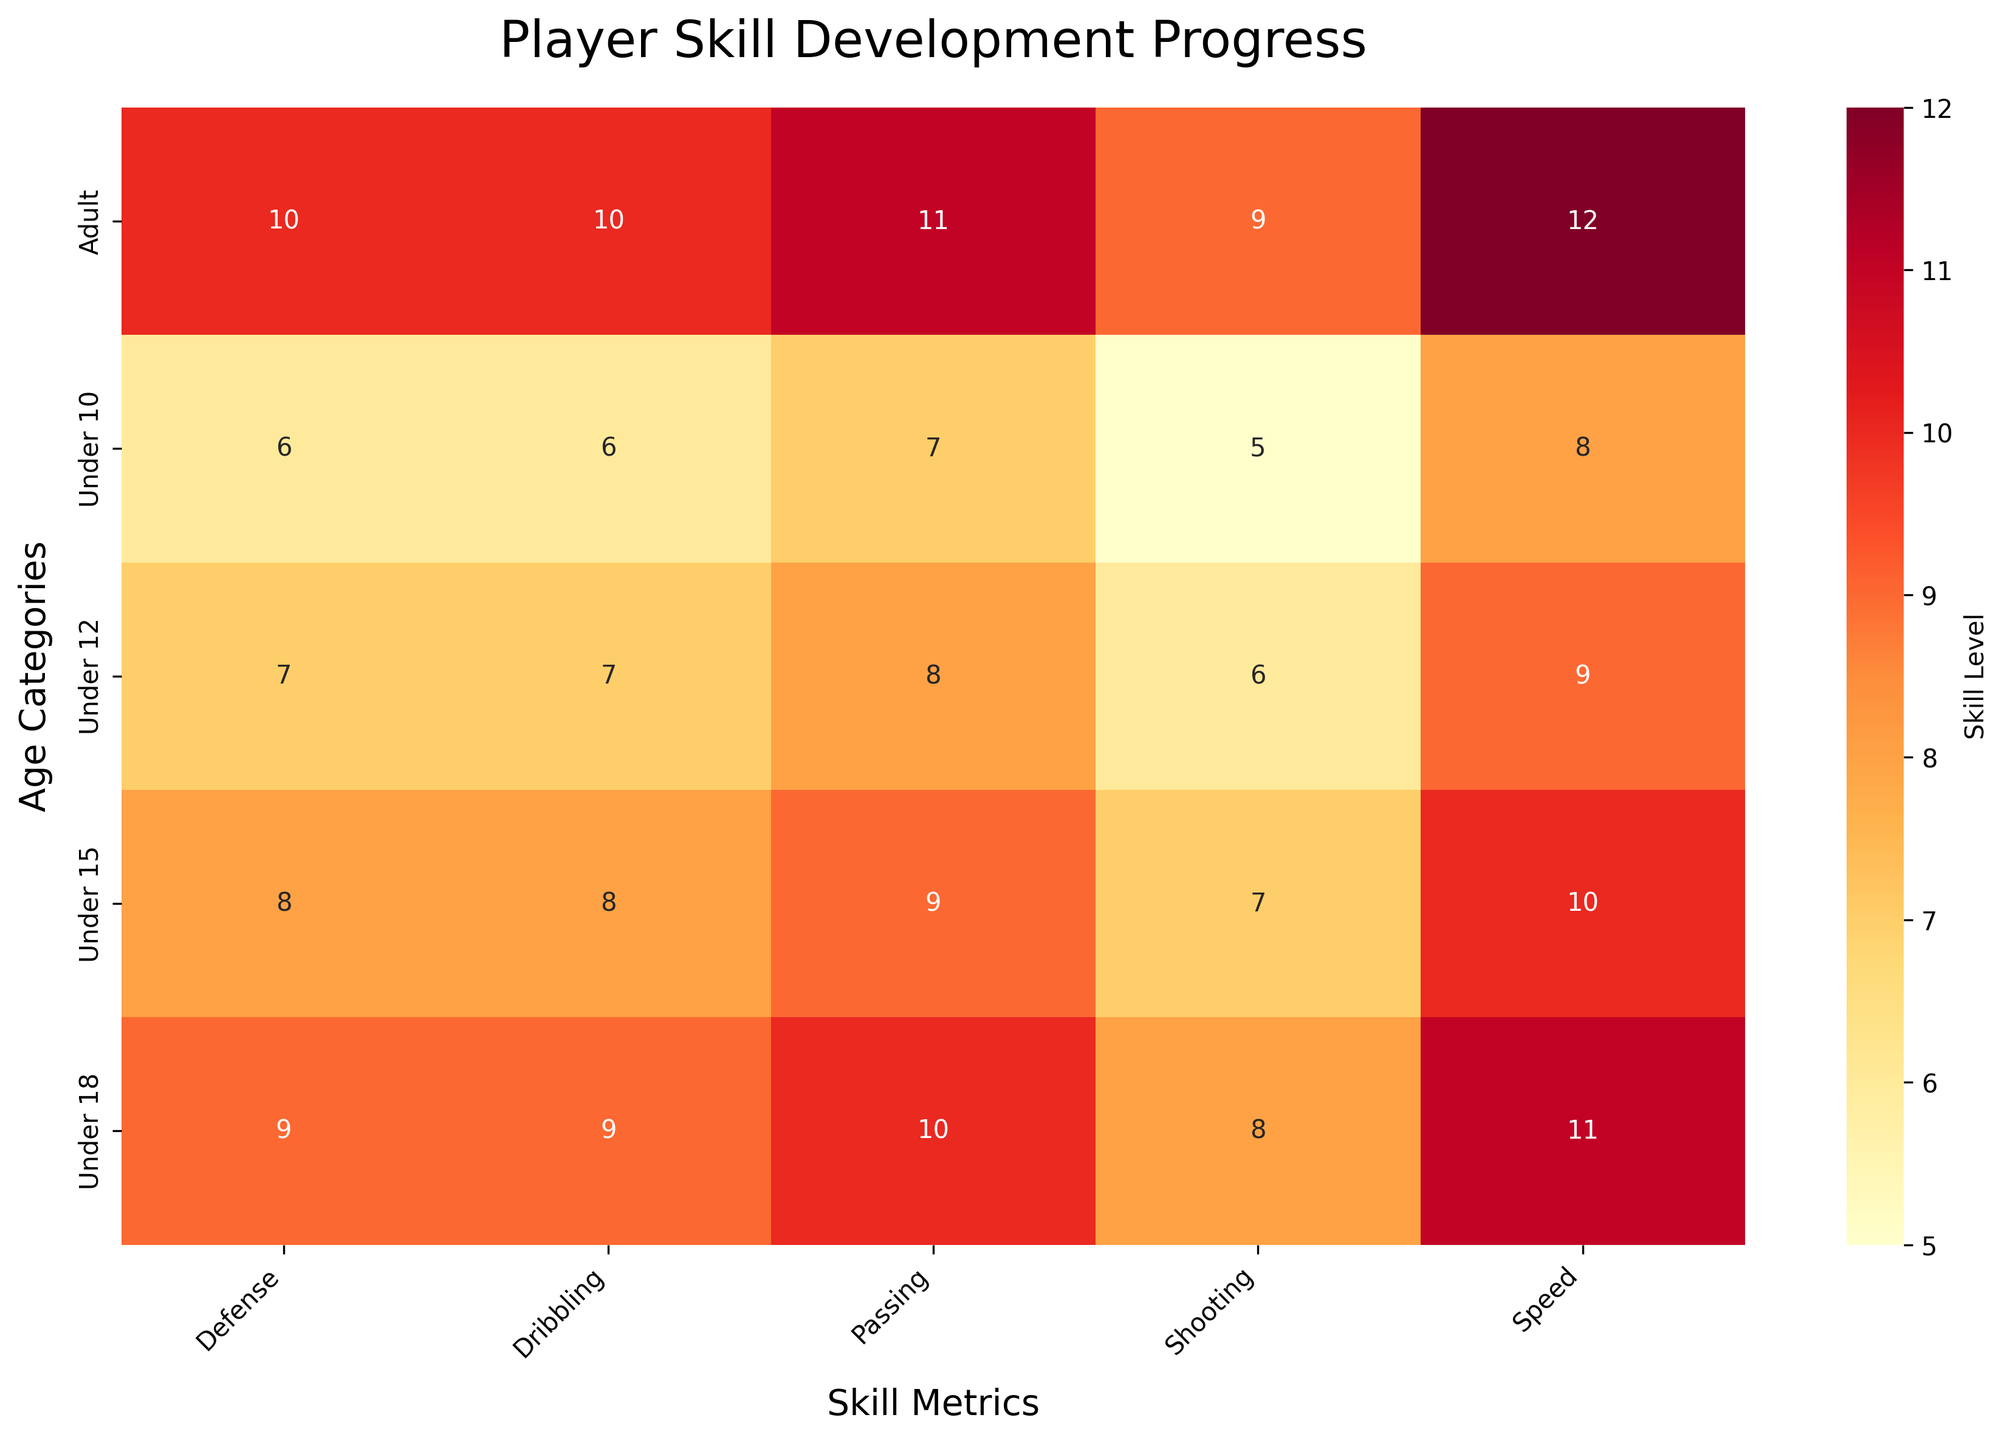What is the title of the heatmap? The title of the heatmap is usually displayed at the top of the plot. In this heatmap, it is "Player Skill Development Progress".
Answer: Player Skill Development Progress Which skill metric has the highest advanced skill level in the Adult age category? To find the highest advanced skill level in the Adult age category, look at the row labeled 'Adult' and identify the highest value among the skill levels.
Answer: Speed How do the advanced skill levels in passing change from Under 10 to Adult? Look at the values in the 'Passing' column for each age category. The advanced skill level increases progressively as age categories advance, specifically: 7 (Under 10), 8 (Under 12), 9 (Under 15), 10 (Under 18), and 11 (Adult).
Answer: They increase steadily Which age category demonstrates the highest average advanced skill level across all skill metrics? To find the highest average advanced skill level, calculate the average for each age category by adding the advanced skill levels and dividing by the number of skill metrics: 
Under 10: (6+7+5+6+8)/5 = 6.4
Under 12: (7+8+6+7+9)/5 = 7.4
Under 15: (8+9+7+8+10)/5 = 8.4
Under 18: (9+10+8+9+11)/5 = 9.4
Adult: (10+11+9+10+12)/5 = 10.4
The category with the highest average is 'Adult'.
Answer: Adult What is the difference in advanced skill level for shooting between Under 10 and Under 18? Locate the advanced skill levels for shooting in the 'Shooting' column for the 'Under 10' and 'Under 18' rows. The values are 5 (Under 10) and 8 (Under 18). The difference is 8 - 5 = 3.
Answer: 3 Which skill shows the least improvement in advanced skill level from Under 10 to Adult? For each skill, subtract the Under 10 value from the Adult value to find the skill with the smallest difference:
Dribbling: 10 - 6 = 4
Passing: 11 - 7 = 4
Shooting: 9 - 5 = 4
Defense: 10 - 6 = 4
Speed: 12 - 8 = 4
All skills show an equal improvement of 4, so there is no skill that shows the least improvement relative to others.
Answer: All skills show equal improvement 